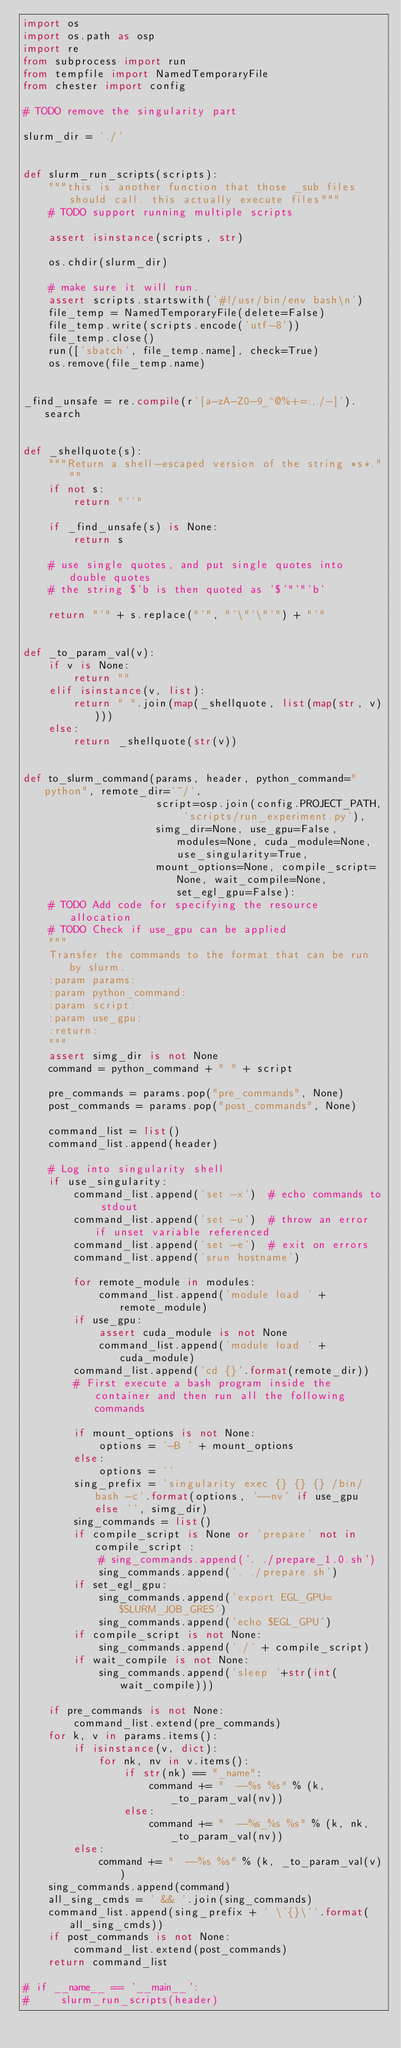<code> <loc_0><loc_0><loc_500><loc_500><_Python_>import os
import os.path as osp
import re
from subprocess import run
from tempfile import NamedTemporaryFile
from chester import config

# TODO remove the singularity part

slurm_dir = './'


def slurm_run_scripts(scripts):
    """this is another function that those _sub files should call. this actually execute files"""
    # TODO support running multiple scripts

    assert isinstance(scripts, str)

    os.chdir(slurm_dir)

    # make sure it will run.
    assert scripts.startswith('#!/usr/bin/env bash\n')
    file_temp = NamedTemporaryFile(delete=False)
    file_temp.write(scripts.encode('utf-8'))
    file_temp.close()
    run(['sbatch', file_temp.name], check=True)
    os.remove(file_temp.name)


_find_unsafe = re.compile(r'[a-zA-Z0-9_^@%+=:,./-]').search


def _shellquote(s):
    """Return a shell-escaped version of the string *s*."""
    if not s:
        return "''"

    if _find_unsafe(s) is None:
        return s

    # use single quotes, and put single quotes into double quotes
    # the string $'b is then quoted as '$'"'"'b'

    return "'" + s.replace("'", "'\"'\"'") + "'"


def _to_param_val(v):
    if v is None:
        return ""
    elif isinstance(v, list):
        return " ".join(map(_shellquote, list(map(str, v))))
    else:
        return _shellquote(str(v))


def to_slurm_command(params, header, python_command="python", remote_dir='~/',
                     script=osp.join(config.PROJECT_PATH, 'scripts/run_experiment.py'),
                     simg_dir=None, use_gpu=False, modules=None, cuda_module=None, use_singularity=True,
                     mount_options=None, compile_script=None, wait_compile=None, set_egl_gpu=False):
    # TODO Add code for specifying the resource allocation
    # TODO Check if use_gpu can be applied
    """
    Transfer the commands to the format that can be run by slurm.
    :param params:
    :param python_command:
    :param script:
    :param use_gpu:
    :return:
    """
    assert simg_dir is not None
    command = python_command + " " + script

    pre_commands = params.pop("pre_commands", None)
    post_commands = params.pop("post_commands", None)

    command_list = list()
    command_list.append(header)

    # Log into singularity shell
    if use_singularity:
        command_list.append('set -x')  # echo commands to stdout
        command_list.append('set -u')  # throw an error if unset variable referenced
        command_list.append('set -e')  # exit on errors
        command_list.append('srun hostname')

        for remote_module in modules:
            command_list.append('module load ' + remote_module)
        if use_gpu:
            assert cuda_module is not None
            command_list.append('module load ' + cuda_module)
        command_list.append('cd {}'.format(remote_dir))
        # First execute a bash program inside the container and then run all the following commands

        if mount_options is not None:
            options = '-B ' + mount_options
        else:
            options = ''
        sing_prefix = 'singularity exec {} {} {} /bin/bash -c'.format(options, '--nv' if use_gpu else '', simg_dir)
        sing_commands = list()
        if compile_script is None or 'prepare' not in compile_script :
            # sing_commands.append('. ./prepare_1.0.sh')
            sing_commands.append('. ./prepare.sh')
        if set_egl_gpu:
            sing_commands.append('export EGL_GPU=$SLURM_JOB_GRES')
            sing_commands.append('echo $EGL_GPU')
        if compile_script is not None:
            sing_commands.append('./' + compile_script)
        if wait_compile is not None:
            sing_commands.append('sleep '+str(int(wait_compile)))

    if pre_commands is not None:
        command_list.extend(pre_commands)
    for k, v in params.items():
        if isinstance(v, dict):
            for nk, nv in v.items():
                if str(nk) == "_name":
                    command += "  --%s %s" % (k, _to_param_val(nv))
                else:
                    command += "  --%s_%s %s" % (k, nk, _to_param_val(nv))
        else:
            command += "  --%s %s" % (k, _to_param_val(v))
    sing_commands.append(command)
    all_sing_cmds = ' && '.join(sing_commands)
    command_list.append(sing_prefix + ' \'{}\''.format(all_sing_cmds))
    if post_commands is not None:
        command_list.extend(post_commands)
    return command_list

# if __name__ == '__main__':
#     slurm_run_scripts(header)
</code> 